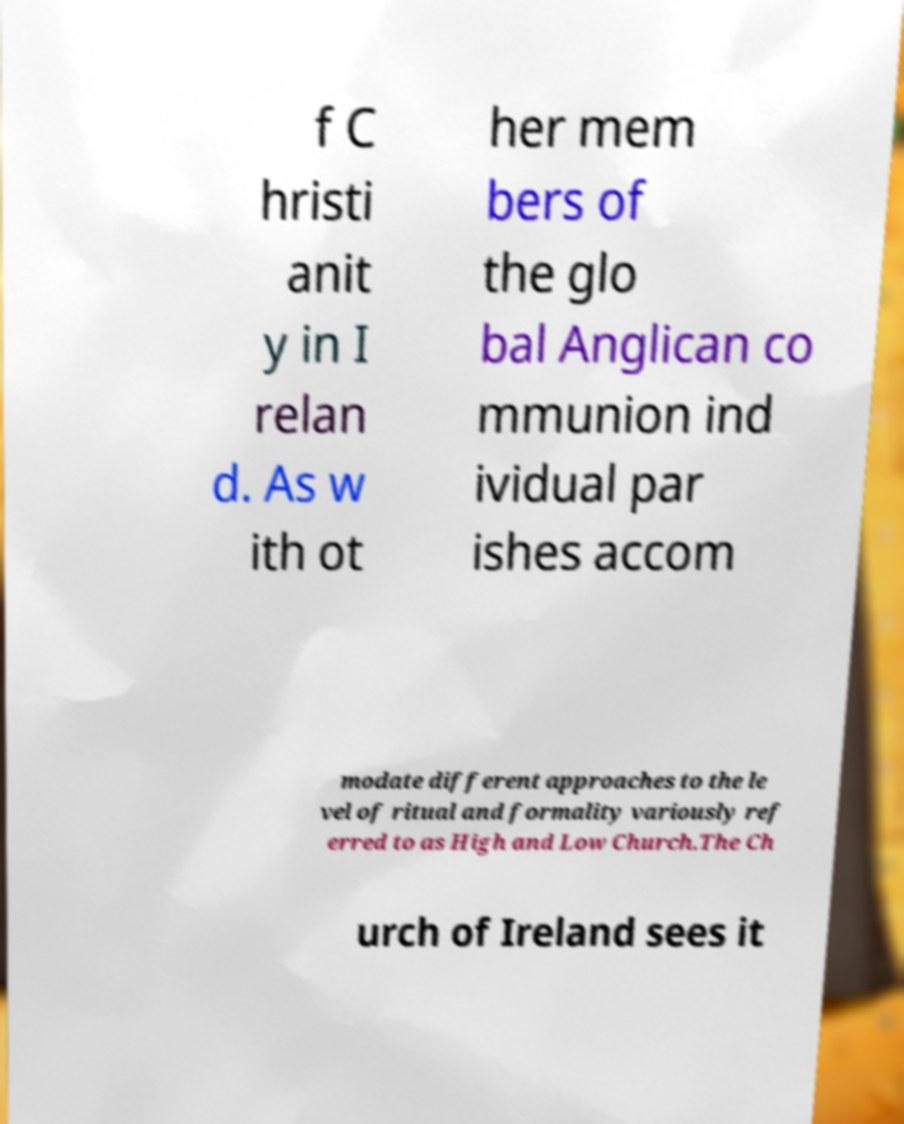Please identify and transcribe the text found in this image. f C hristi anit y in I relan d. As w ith ot her mem bers of the glo bal Anglican co mmunion ind ividual par ishes accom modate different approaches to the le vel of ritual and formality variously ref erred to as High and Low Church.The Ch urch of Ireland sees it 